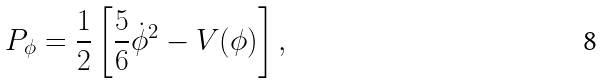Convert formula to latex. <formula><loc_0><loc_0><loc_500><loc_500>P _ { \phi } = \frac { 1 } { 2 } \left [ \frac { 5 } { 6 } \dot { \phi } ^ { 2 } - V ( \phi ) \right ] ,</formula> 